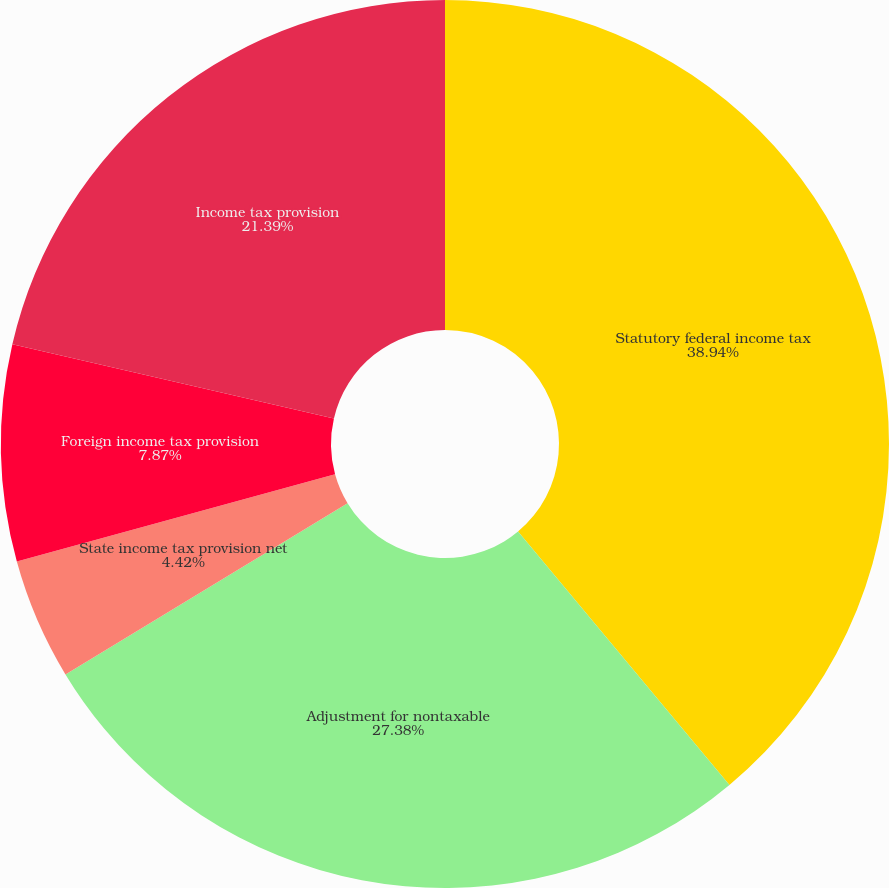Convert chart to OTSL. <chart><loc_0><loc_0><loc_500><loc_500><pie_chart><fcel>Statutory federal income tax<fcel>Adjustment for nontaxable<fcel>State income tax provision net<fcel>Foreign income tax provision<fcel>Income tax provision<nl><fcel>38.93%<fcel>27.38%<fcel>4.42%<fcel>7.87%<fcel>21.39%<nl></chart> 